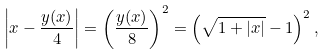Convert formula to latex. <formula><loc_0><loc_0><loc_500><loc_500>\left | x - \frac { y ( x ) } { 4 } \right | = \left ( \frac { y ( x ) } { 8 } \right ) ^ { 2 } = \left ( \sqrt { 1 + | x | } - 1 \right ) ^ { 2 } ,</formula> 